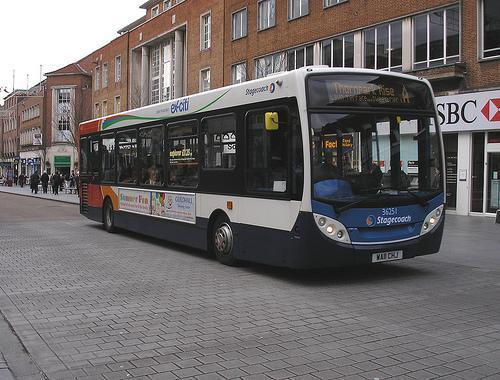How many tires are shown?
Give a very brief answer. 2. 